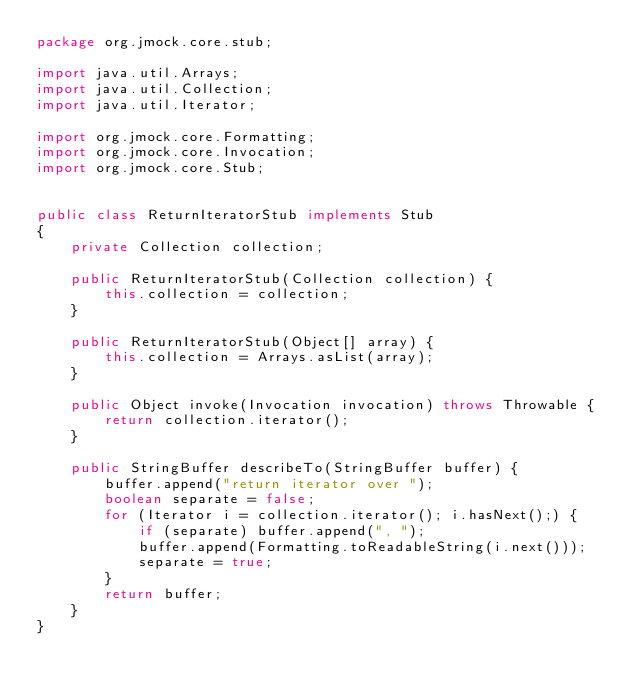<code> <loc_0><loc_0><loc_500><loc_500><_Java_>package org.jmock.core.stub;

import java.util.Arrays;
import java.util.Collection;
import java.util.Iterator;

import org.jmock.core.Formatting;
import org.jmock.core.Invocation;
import org.jmock.core.Stub;


public class ReturnIteratorStub implements Stub 
{
    private Collection collection;
    
    public ReturnIteratorStub(Collection collection) {
        this.collection = collection;
    }
    
    public ReturnIteratorStub(Object[] array) {
        this.collection = Arrays.asList(array);
    }
    
    public Object invoke(Invocation invocation) throws Throwable {
        return collection.iterator();
    }
    
    public StringBuffer describeTo(StringBuffer buffer) {
        buffer.append("return iterator over ");
        boolean separate = false;
        for (Iterator i = collection.iterator(); i.hasNext();) {
            if (separate) buffer.append(", ");
            buffer.append(Formatting.toReadableString(i.next()));
            separate = true;
        }
        return buffer;
    }
}
</code> 